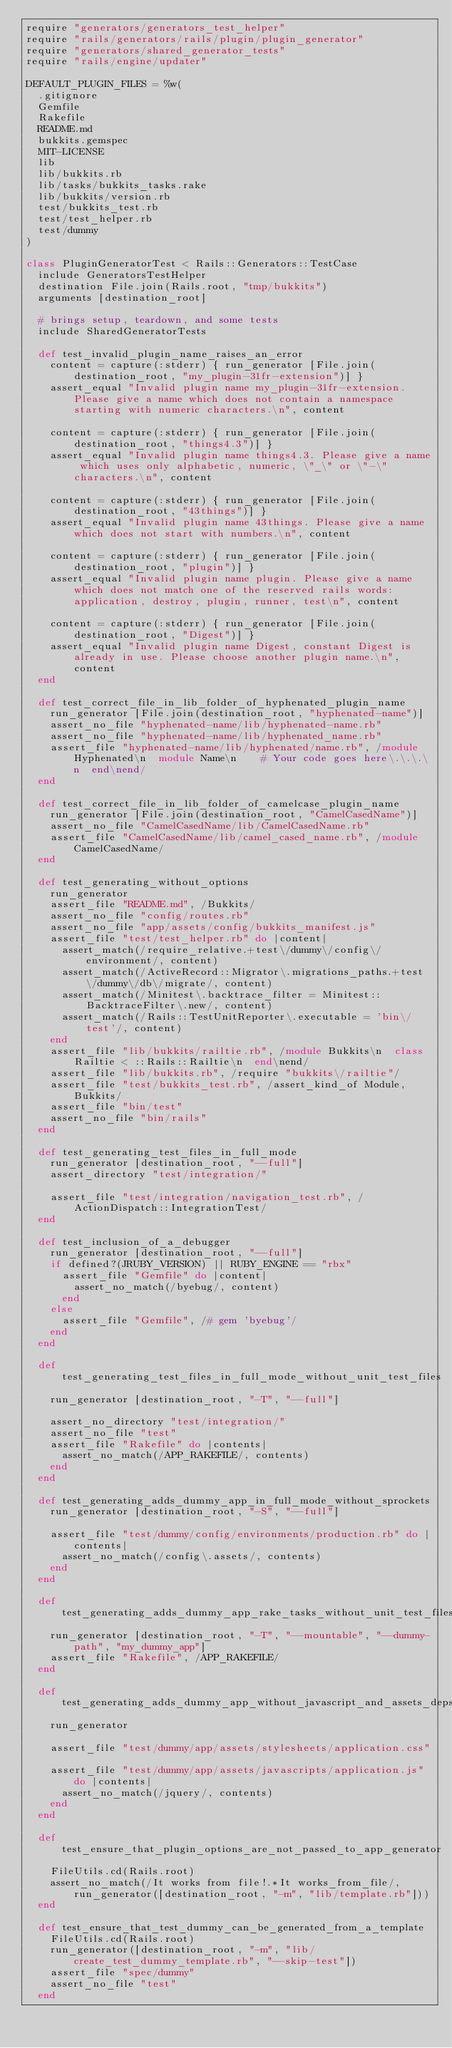Convert code to text. <code><loc_0><loc_0><loc_500><loc_500><_Ruby_>require "generators/generators_test_helper"
require "rails/generators/rails/plugin/plugin_generator"
require "generators/shared_generator_tests"
require "rails/engine/updater"

DEFAULT_PLUGIN_FILES = %w(
  .gitignore
  Gemfile
  Rakefile
  README.md
  bukkits.gemspec
  MIT-LICENSE
  lib
  lib/bukkits.rb
  lib/tasks/bukkits_tasks.rake
  lib/bukkits/version.rb
  test/bukkits_test.rb
  test/test_helper.rb
  test/dummy
)

class PluginGeneratorTest < Rails::Generators::TestCase
  include GeneratorsTestHelper
  destination File.join(Rails.root, "tmp/bukkits")
  arguments [destination_root]

  # brings setup, teardown, and some tests
  include SharedGeneratorTests

  def test_invalid_plugin_name_raises_an_error
    content = capture(:stderr) { run_generator [File.join(destination_root, "my_plugin-31fr-extension")] }
    assert_equal "Invalid plugin name my_plugin-31fr-extension. Please give a name which does not contain a namespace starting with numeric characters.\n", content

    content = capture(:stderr) { run_generator [File.join(destination_root, "things4.3")] }
    assert_equal "Invalid plugin name things4.3. Please give a name which uses only alphabetic, numeric, \"_\" or \"-\" characters.\n", content

    content = capture(:stderr) { run_generator [File.join(destination_root, "43things")] }
    assert_equal "Invalid plugin name 43things. Please give a name which does not start with numbers.\n", content

    content = capture(:stderr) { run_generator [File.join(destination_root, "plugin")] }
    assert_equal "Invalid plugin name plugin. Please give a name which does not match one of the reserved rails words: application, destroy, plugin, runner, test\n", content

    content = capture(:stderr) { run_generator [File.join(destination_root, "Digest")] }
    assert_equal "Invalid plugin name Digest, constant Digest is already in use. Please choose another plugin name.\n", content
  end

  def test_correct_file_in_lib_folder_of_hyphenated_plugin_name
    run_generator [File.join(destination_root, "hyphenated-name")]
    assert_no_file "hyphenated-name/lib/hyphenated-name.rb"
    assert_no_file "hyphenated-name/lib/hyphenated_name.rb"
    assert_file "hyphenated-name/lib/hyphenated/name.rb", /module Hyphenated\n  module Name\n    # Your code goes here\.\.\.\n  end\nend/
  end

  def test_correct_file_in_lib_folder_of_camelcase_plugin_name
    run_generator [File.join(destination_root, "CamelCasedName")]
    assert_no_file "CamelCasedName/lib/CamelCasedName.rb"
    assert_file "CamelCasedName/lib/camel_cased_name.rb", /module CamelCasedName/
  end

  def test_generating_without_options
    run_generator
    assert_file "README.md", /Bukkits/
    assert_no_file "config/routes.rb"
    assert_no_file "app/assets/config/bukkits_manifest.js"
    assert_file "test/test_helper.rb" do |content|
      assert_match(/require_relative.+test\/dummy\/config\/environment/, content)
      assert_match(/ActiveRecord::Migrator\.migrations_paths.+test\/dummy\/db\/migrate/, content)
      assert_match(/Minitest\.backtrace_filter = Minitest::BacktraceFilter\.new/, content)
      assert_match(/Rails::TestUnitReporter\.executable = 'bin\/test'/, content)
    end
    assert_file "lib/bukkits/railtie.rb", /module Bukkits\n  class Railtie < ::Rails::Railtie\n  end\nend/
    assert_file "lib/bukkits.rb", /require "bukkits\/railtie"/
    assert_file "test/bukkits_test.rb", /assert_kind_of Module, Bukkits/
    assert_file "bin/test"
    assert_no_file "bin/rails"
  end

  def test_generating_test_files_in_full_mode
    run_generator [destination_root, "--full"]
    assert_directory "test/integration/"

    assert_file "test/integration/navigation_test.rb", /ActionDispatch::IntegrationTest/
  end

  def test_inclusion_of_a_debugger
    run_generator [destination_root, "--full"]
    if defined?(JRUBY_VERSION) || RUBY_ENGINE == "rbx"
      assert_file "Gemfile" do |content|
        assert_no_match(/byebug/, content)
      end
    else
      assert_file "Gemfile", /# gem 'byebug'/
    end
  end

  def test_generating_test_files_in_full_mode_without_unit_test_files
    run_generator [destination_root, "-T", "--full"]

    assert_no_directory "test/integration/"
    assert_no_file "test"
    assert_file "Rakefile" do |contents|
      assert_no_match(/APP_RAKEFILE/, contents)
    end
  end

  def test_generating_adds_dummy_app_in_full_mode_without_sprockets
    run_generator [destination_root, "-S", "--full"]

    assert_file "test/dummy/config/environments/production.rb" do |contents|
      assert_no_match(/config\.assets/, contents)
    end
  end

  def test_generating_adds_dummy_app_rake_tasks_without_unit_test_files
    run_generator [destination_root, "-T", "--mountable", "--dummy-path", "my_dummy_app"]
    assert_file "Rakefile", /APP_RAKEFILE/
  end

  def test_generating_adds_dummy_app_without_javascript_and_assets_deps
    run_generator

    assert_file "test/dummy/app/assets/stylesheets/application.css"

    assert_file "test/dummy/app/assets/javascripts/application.js" do |contents|
      assert_no_match(/jquery/, contents)
    end
  end

  def test_ensure_that_plugin_options_are_not_passed_to_app_generator
    FileUtils.cd(Rails.root)
    assert_no_match(/It works from file!.*It works_from_file/, run_generator([destination_root, "-m", "lib/template.rb"]))
  end

  def test_ensure_that_test_dummy_can_be_generated_from_a_template
    FileUtils.cd(Rails.root)
    run_generator([destination_root, "-m", "lib/create_test_dummy_template.rb", "--skip-test"])
    assert_file "spec/dummy"
    assert_no_file "test"
  end
</code> 